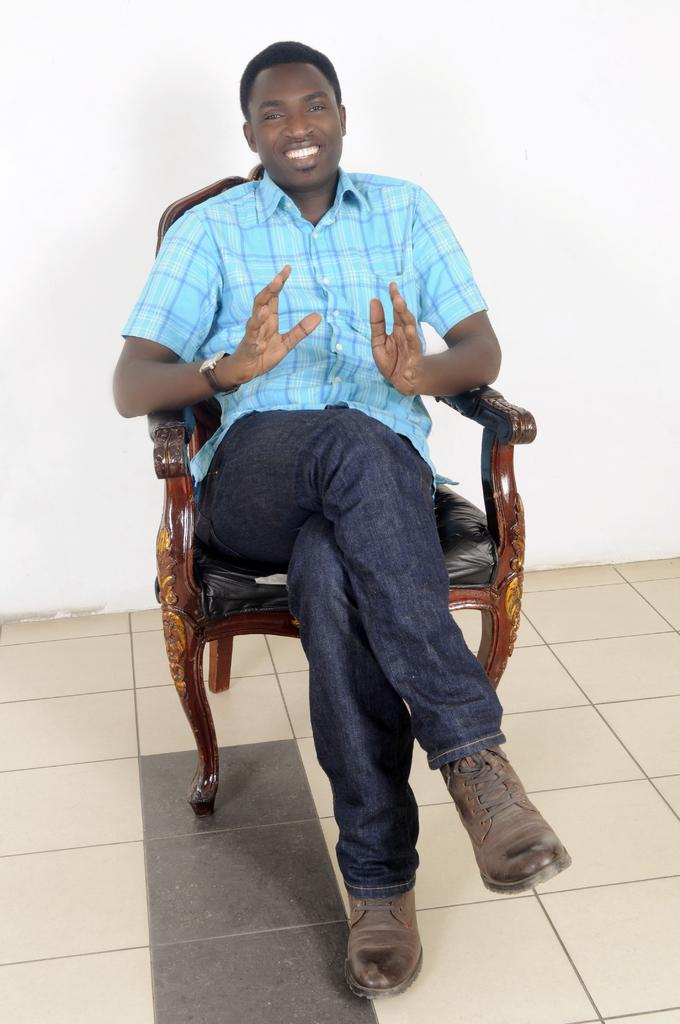Who or what is present in the image? There is a person in the image. What is the person doing in the image? The person is sitting on a chair. How does the person appear to be feeling in the image? The person is smiling, which suggests they are happy or content. What type of cable can be seen in the image? There is no cable present in the image. 